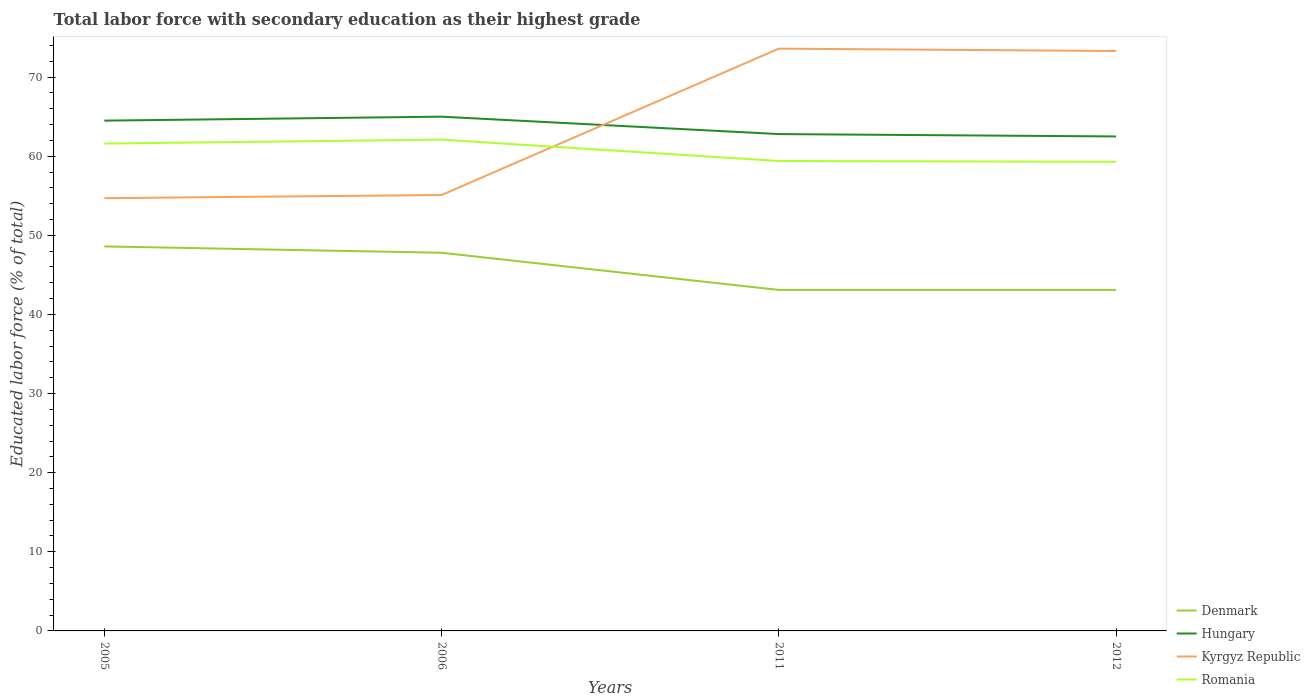How many different coloured lines are there?
Your answer should be very brief. 4. Does the line corresponding to Hungary intersect with the line corresponding to Romania?
Your response must be concise. No. Is the number of lines equal to the number of legend labels?
Your answer should be very brief. Yes. Across all years, what is the maximum percentage of total labor force with primary education in Kyrgyz Republic?
Make the answer very short. 54.7. In which year was the percentage of total labor force with primary education in Denmark maximum?
Offer a terse response. 2011. What is the total percentage of total labor force with primary education in Hungary in the graph?
Provide a short and direct response. -0.5. What is the difference between the highest and the second highest percentage of total labor force with primary education in Romania?
Offer a very short reply. 2.8. Is the percentage of total labor force with primary education in Kyrgyz Republic strictly greater than the percentage of total labor force with primary education in Denmark over the years?
Your response must be concise. No. How many years are there in the graph?
Offer a terse response. 4. Are the values on the major ticks of Y-axis written in scientific E-notation?
Provide a short and direct response. No. How many legend labels are there?
Give a very brief answer. 4. What is the title of the graph?
Provide a succinct answer. Total labor force with secondary education as their highest grade. What is the label or title of the Y-axis?
Offer a very short reply. Educated labor force (% of total). What is the Educated labor force (% of total) of Denmark in 2005?
Offer a very short reply. 48.6. What is the Educated labor force (% of total) of Hungary in 2005?
Provide a succinct answer. 64.5. What is the Educated labor force (% of total) of Kyrgyz Republic in 2005?
Offer a very short reply. 54.7. What is the Educated labor force (% of total) of Romania in 2005?
Provide a short and direct response. 61.6. What is the Educated labor force (% of total) of Denmark in 2006?
Your response must be concise. 47.8. What is the Educated labor force (% of total) in Hungary in 2006?
Your answer should be compact. 65. What is the Educated labor force (% of total) in Kyrgyz Republic in 2006?
Keep it short and to the point. 55.1. What is the Educated labor force (% of total) in Romania in 2006?
Give a very brief answer. 62.1. What is the Educated labor force (% of total) of Denmark in 2011?
Your response must be concise. 43.1. What is the Educated labor force (% of total) in Hungary in 2011?
Offer a terse response. 62.8. What is the Educated labor force (% of total) in Kyrgyz Republic in 2011?
Make the answer very short. 73.6. What is the Educated labor force (% of total) in Romania in 2011?
Offer a very short reply. 59.4. What is the Educated labor force (% of total) of Denmark in 2012?
Give a very brief answer. 43.1. What is the Educated labor force (% of total) of Hungary in 2012?
Make the answer very short. 62.5. What is the Educated labor force (% of total) in Kyrgyz Republic in 2012?
Provide a succinct answer. 73.3. What is the Educated labor force (% of total) in Romania in 2012?
Your answer should be compact. 59.3. Across all years, what is the maximum Educated labor force (% of total) in Denmark?
Your response must be concise. 48.6. Across all years, what is the maximum Educated labor force (% of total) of Hungary?
Your answer should be very brief. 65. Across all years, what is the maximum Educated labor force (% of total) in Kyrgyz Republic?
Offer a very short reply. 73.6. Across all years, what is the maximum Educated labor force (% of total) of Romania?
Ensure brevity in your answer.  62.1. Across all years, what is the minimum Educated labor force (% of total) of Denmark?
Offer a terse response. 43.1. Across all years, what is the minimum Educated labor force (% of total) in Hungary?
Your answer should be compact. 62.5. Across all years, what is the minimum Educated labor force (% of total) of Kyrgyz Republic?
Give a very brief answer. 54.7. Across all years, what is the minimum Educated labor force (% of total) in Romania?
Offer a terse response. 59.3. What is the total Educated labor force (% of total) in Denmark in the graph?
Give a very brief answer. 182.6. What is the total Educated labor force (% of total) in Hungary in the graph?
Your answer should be very brief. 254.8. What is the total Educated labor force (% of total) of Kyrgyz Republic in the graph?
Provide a short and direct response. 256.7. What is the total Educated labor force (% of total) in Romania in the graph?
Your answer should be very brief. 242.4. What is the difference between the Educated labor force (% of total) of Denmark in 2005 and that in 2006?
Make the answer very short. 0.8. What is the difference between the Educated labor force (% of total) of Hungary in 2005 and that in 2006?
Make the answer very short. -0.5. What is the difference between the Educated labor force (% of total) of Romania in 2005 and that in 2006?
Keep it short and to the point. -0.5. What is the difference between the Educated labor force (% of total) in Hungary in 2005 and that in 2011?
Your answer should be compact. 1.7. What is the difference between the Educated labor force (% of total) of Kyrgyz Republic in 2005 and that in 2011?
Provide a short and direct response. -18.9. What is the difference between the Educated labor force (% of total) in Romania in 2005 and that in 2011?
Give a very brief answer. 2.2. What is the difference between the Educated labor force (% of total) in Hungary in 2005 and that in 2012?
Offer a terse response. 2. What is the difference between the Educated labor force (% of total) of Kyrgyz Republic in 2005 and that in 2012?
Offer a very short reply. -18.6. What is the difference between the Educated labor force (% of total) in Hungary in 2006 and that in 2011?
Offer a terse response. 2.2. What is the difference between the Educated labor force (% of total) of Kyrgyz Republic in 2006 and that in 2011?
Offer a terse response. -18.5. What is the difference between the Educated labor force (% of total) of Romania in 2006 and that in 2011?
Provide a short and direct response. 2.7. What is the difference between the Educated labor force (% of total) of Denmark in 2006 and that in 2012?
Give a very brief answer. 4.7. What is the difference between the Educated labor force (% of total) of Kyrgyz Republic in 2006 and that in 2012?
Provide a succinct answer. -18.2. What is the difference between the Educated labor force (% of total) of Romania in 2011 and that in 2012?
Make the answer very short. 0.1. What is the difference between the Educated labor force (% of total) of Denmark in 2005 and the Educated labor force (% of total) of Hungary in 2006?
Give a very brief answer. -16.4. What is the difference between the Educated labor force (% of total) of Denmark in 2005 and the Educated labor force (% of total) of Kyrgyz Republic in 2006?
Give a very brief answer. -6.5. What is the difference between the Educated labor force (% of total) of Denmark in 2005 and the Educated labor force (% of total) of Hungary in 2011?
Offer a terse response. -14.2. What is the difference between the Educated labor force (% of total) of Denmark in 2005 and the Educated labor force (% of total) of Romania in 2011?
Keep it short and to the point. -10.8. What is the difference between the Educated labor force (% of total) of Hungary in 2005 and the Educated labor force (% of total) of Kyrgyz Republic in 2011?
Provide a succinct answer. -9.1. What is the difference between the Educated labor force (% of total) in Hungary in 2005 and the Educated labor force (% of total) in Romania in 2011?
Your answer should be very brief. 5.1. What is the difference between the Educated labor force (% of total) in Kyrgyz Republic in 2005 and the Educated labor force (% of total) in Romania in 2011?
Your answer should be compact. -4.7. What is the difference between the Educated labor force (% of total) in Denmark in 2005 and the Educated labor force (% of total) in Kyrgyz Republic in 2012?
Provide a short and direct response. -24.7. What is the difference between the Educated labor force (% of total) in Hungary in 2005 and the Educated labor force (% of total) in Kyrgyz Republic in 2012?
Make the answer very short. -8.8. What is the difference between the Educated labor force (% of total) of Denmark in 2006 and the Educated labor force (% of total) of Hungary in 2011?
Provide a short and direct response. -15. What is the difference between the Educated labor force (% of total) in Denmark in 2006 and the Educated labor force (% of total) in Kyrgyz Republic in 2011?
Give a very brief answer. -25.8. What is the difference between the Educated labor force (% of total) of Denmark in 2006 and the Educated labor force (% of total) of Romania in 2011?
Provide a short and direct response. -11.6. What is the difference between the Educated labor force (% of total) of Hungary in 2006 and the Educated labor force (% of total) of Kyrgyz Republic in 2011?
Offer a terse response. -8.6. What is the difference between the Educated labor force (% of total) of Kyrgyz Republic in 2006 and the Educated labor force (% of total) of Romania in 2011?
Provide a succinct answer. -4.3. What is the difference between the Educated labor force (% of total) in Denmark in 2006 and the Educated labor force (% of total) in Hungary in 2012?
Offer a very short reply. -14.7. What is the difference between the Educated labor force (% of total) in Denmark in 2006 and the Educated labor force (% of total) in Kyrgyz Republic in 2012?
Your answer should be very brief. -25.5. What is the difference between the Educated labor force (% of total) of Denmark in 2006 and the Educated labor force (% of total) of Romania in 2012?
Keep it short and to the point. -11.5. What is the difference between the Educated labor force (% of total) in Hungary in 2006 and the Educated labor force (% of total) in Romania in 2012?
Give a very brief answer. 5.7. What is the difference between the Educated labor force (% of total) in Kyrgyz Republic in 2006 and the Educated labor force (% of total) in Romania in 2012?
Keep it short and to the point. -4.2. What is the difference between the Educated labor force (% of total) of Denmark in 2011 and the Educated labor force (% of total) of Hungary in 2012?
Make the answer very short. -19.4. What is the difference between the Educated labor force (% of total) of Denmark in 2011 and the Educated labor force (% of total) of Kyrgyz Republic in 2012?
Keep it short and to the point. -30.2. What is the difference between the Educated labor force (% of total) of Denmark in 2011 and the Educated labor force (% of total) of Romania in 2012?
Offer a very short reply. -16.2. What is the average Educated labor force (% of total) of Denmark per year?
Provide a short and direct response. 45.65. What is the average Educated labor force (% of total) of Hungary per year?
Your answer should be compact. 63.7. What is the average Educated labor force (% of total) of Kyrgyz Republic per year?
Your response must be concise. 64.17. What is the average Educated labor force (% of total) of Romania per year?
Offer a very short reply. 60.6. In the year 2005, what is the difference between the Educated labor force (% of total) in Denmark and Educated labor force (% of total) in Hungary?
Keep it short and to the point. -15.9. In the year 2005, what is the difference between the Educated labor force (% of total) of Hungary and Educated labor force (% of total) of Romania?
Ensure brevity in your answer.  2.9. In the year 2006, what is the difference between the Educated labor force (% of total) in Denmark and Educated labor force (% of total) in Hungary?
Provide a short and direct response. -17.2. In the year 2006, what is the difference between the Educated labor force (% of total) in Denmark and Educated labor force (% of total) in Romania?
Ensure brevity in your answer.  -14.3. In the year 2006, what is the difference between the Educated labor force (% of total) of Hungary and Educated labor force (% of total) of Kyrgyz Republic?
Your answer should be compact. 9.9. In the year 2006, what is the difference between the Educated labor force (% of total) in Kyrgyz Republic and Educated labor force (% of total) in Romania?
Ensure brevity in your answer.  -7. In the year 2011, what is the difference between the Educated labor force (% of total) of Denmark and Educated labor force (% of total) of Hungary?
Offer a very short reply. -19.7. In the year 2011, what is the difference between the Educated labor force (% of total) of Denmark and Educated labor force (% of total) of Kyrgyz Republic?
Offer a terse response. -30.5. In the year 2011, what is the difference between the Educated labor force (% of total) in Denmark and Educated labor force (% of total) in Romania?
Ensure brevity in your answer.  -16.3. In the year 2011, what is the difference between the Educated labor force (% of total) of Kyrgyz Republic and Educated labor force (% of total) of Romania?
Offer a terse response. 14.2. In the year 2012, what is the difference between the Educated labor force (% of total) in Denmark and Educated labor force (% of total) in Hungary?
Make the answer very short. -19.4. In the year 2012, what is the difference between the Educated labor force (% of total) in Denmark and Educated labor force (% of total) in Kyrgyz Republic?
Keep it short and to the point. -30.2. In the year 2012, what is the difference between the Educated labor force (% of total) in Denmark and Educated labor force (% of total) in Romania?
Your answer should be compact. -16.2. In the year 2012, what is the difference between the Educated labor force (% of total) in Kyrgyz Republic and Educated labor force (% of total) in Romania?
Provide a succinct answer. 14. What is the ratio of the Educated labor force (% of total) of Denmark in 2005 to that in 2006?
Offer a terse response. 1.02. What is the ratio of the Educated labor force (% of total) of Hungary in 2005 to that in 2006?
Your answer should be compact. 0.99. What is the ratio of the Educated labor force (% of total) of Denmark in 2005 to that in 2011?
Your answer should be very brief. 1.13. What is the ratio of the Educated labor force (% of total) in Hungary in 2005 to that in 2011?
Ensure brevity in your answer.  1.03. What is the ratio of the Educated labor force (% of total) in Kyrgyz Republic in 2005 to that in 2011?
Offer a terse response. 0.74. What is the ratio of the Educated labor force (% of total) in Denmark in 2005 to that in 2012?
Your response must be concise. 1.13. What is the ratio of the Educated labor force (% of total) in Hungary in 2005 to that in 2012?
Provide a short and direct response. 1.03. What is the ratio of the Educated labor force (% of total) in Kyrgyz Republic in 2005 to that in 2012?
Your answer should be compact. 0.75. What is the ratio of the Educated labor force (% of total) of Romania in 2005 to that in 2012?
Provide a succinct answer. 1.04. What is the ratio of the Educated labor force (% of total) of Denmark in 2006 to that in 2011?
Your answer should be compact. 1.11. What is the ratio of the Educated labor force (% of total) of Hungary in 2006 to that in 2011?
Offer a terse response. 1.03. What is the ratio of the Educated labor force (% of total) of Kyrgyz Republic in 2006 to that in 2011?
Your answer should be compact. 0.75. What is the ratio of the Educated labor force (% of total) of Romania in 2006 to that in 2011?
Give a very brief answer. 1.05. What is the ratio of the Educated labor force (% of total) in Denmark in 2006 to that in 2012?
Make the answer very short. 1.11. What is the ratio of the Educated labor force (% of total) in Hungary in 2006 to that in 2012?
Your answer should be very brief. 1.04. What is the ratio of the Educated labor force (% of total) in Kyrgyz Republic in 2006 to that in 2012?
Ensure brevity in your answer.  0.75. What is the ratio of the Educated labor force (% of total) of Romania in 2006 to that in 2012?
Make the answer very short. 1.05. What is the ratio of the Educated labor force (% of total) in Denmark in 2011 to that in 2012?
Your answer should be very brief. 1. What is the ratio of the Educated labor force (% of total) of Kyrgyz Republic in 2011 to that in 2012?
Make the answer very short. 1. What is the ratio of the Educated labor force (% of total) of Romania in 2011 to that in 2012?
Offer a very short reply. 1. What is the difference between the highest and the second highest Educated labor force (% of total) in Hungary?
Your answer should be compact. 0.5. 